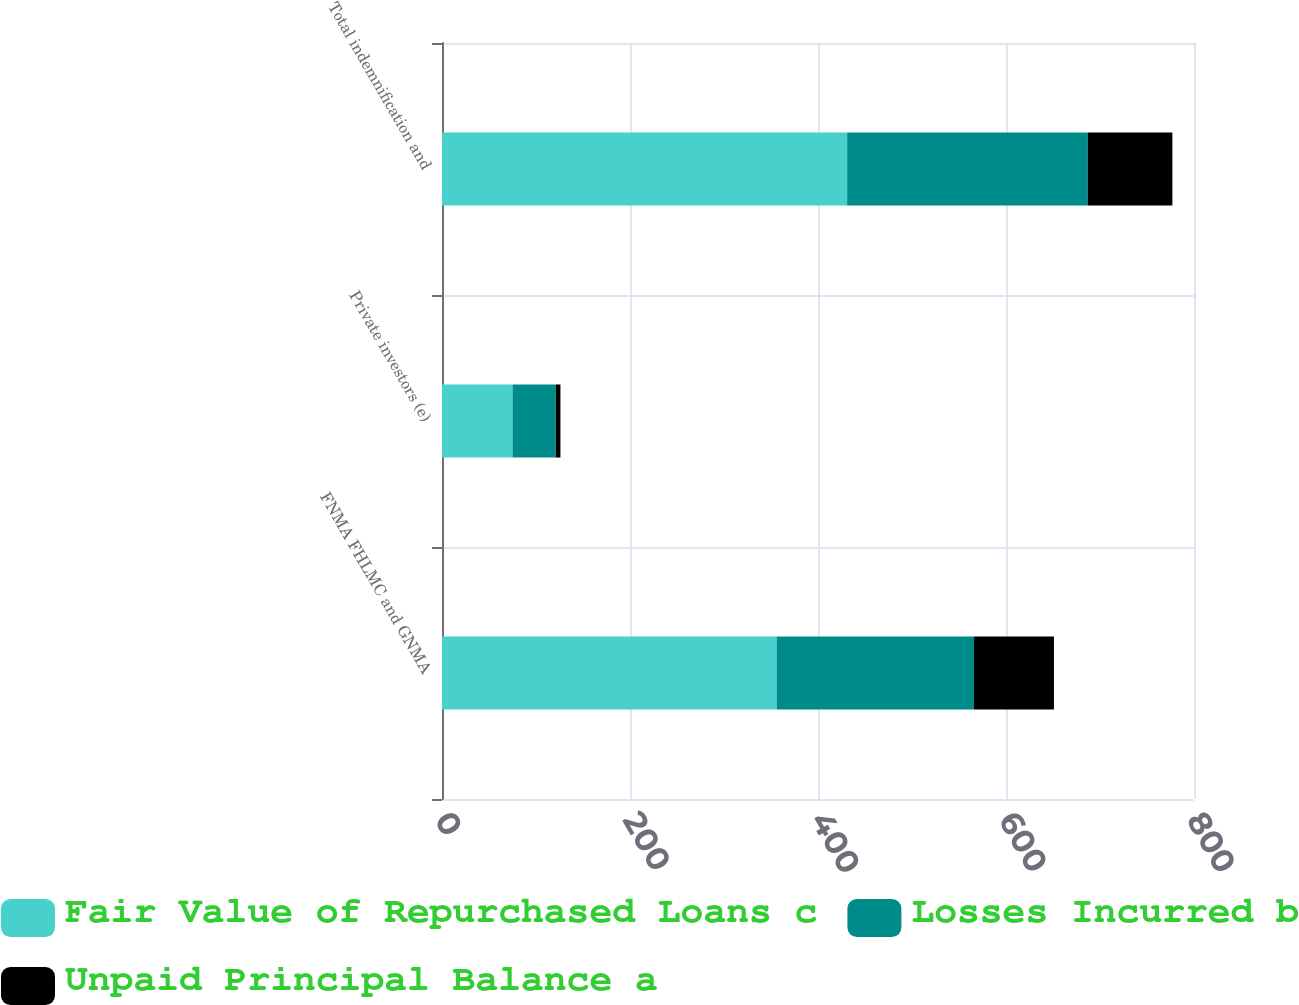<chart> <loc_0><loc_0><loc_500><loc_500><stacked_bar_chart><ecel><fcel>FNMA FHLMC and GNMA<fcel>Private investors (e)<fcel>Total indemnification and<nl><fcel>Fair Value of Repurchased Loans c<fcel>356<fcel>75<fcel>431<nl><fcel>Losses Incurred b<fcel>210<fcel>46<fcel>256<nl><fcel>Unpaid Principal Balance a<fcel>85<fcel>5<fcel>90<nl></chart> 